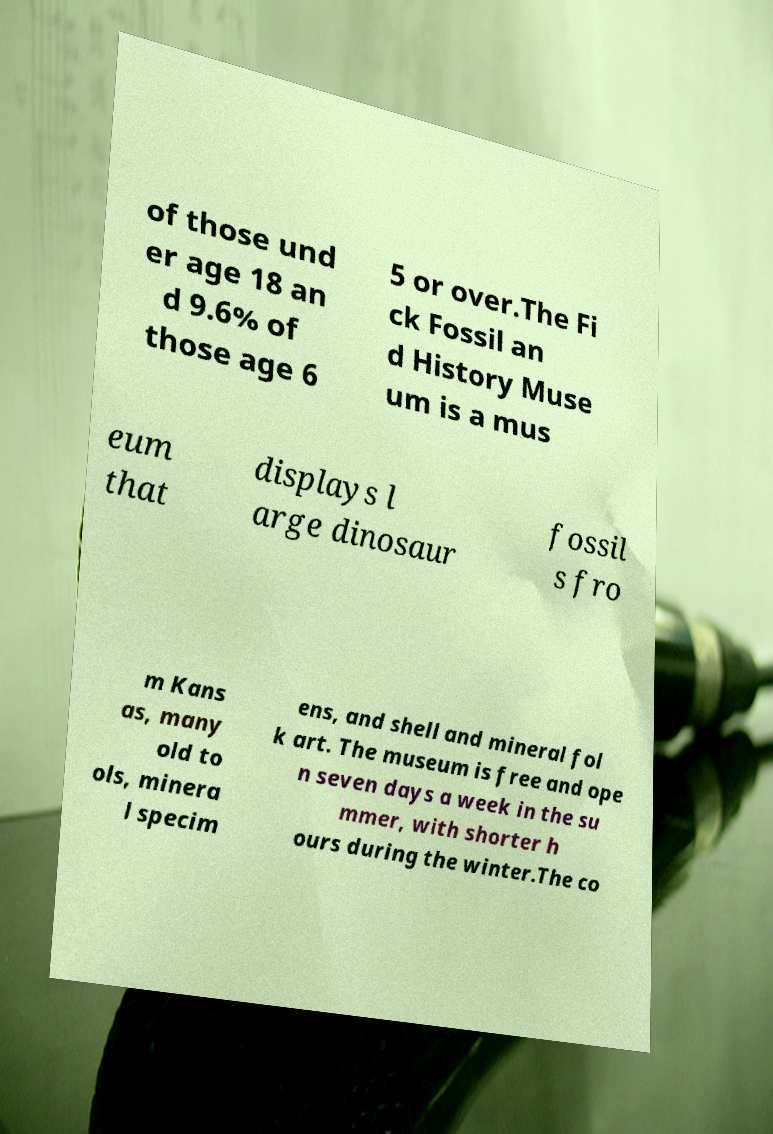There's text embedded in this image that I need extracted. Can you transcribe it verbatim? of those und er age 18 an d 9.6% of those age 6 5 or over.The Fi ck Fossil an d History Muse um is a mus eum that displays l arge dinosaur fossil s fro m Kans as, many old to ols, minera l specim ens, and shell and mineral fol k art. The museum is free and ope n seven days a week in the su mmer, with shorter h ours during the winter.The co 